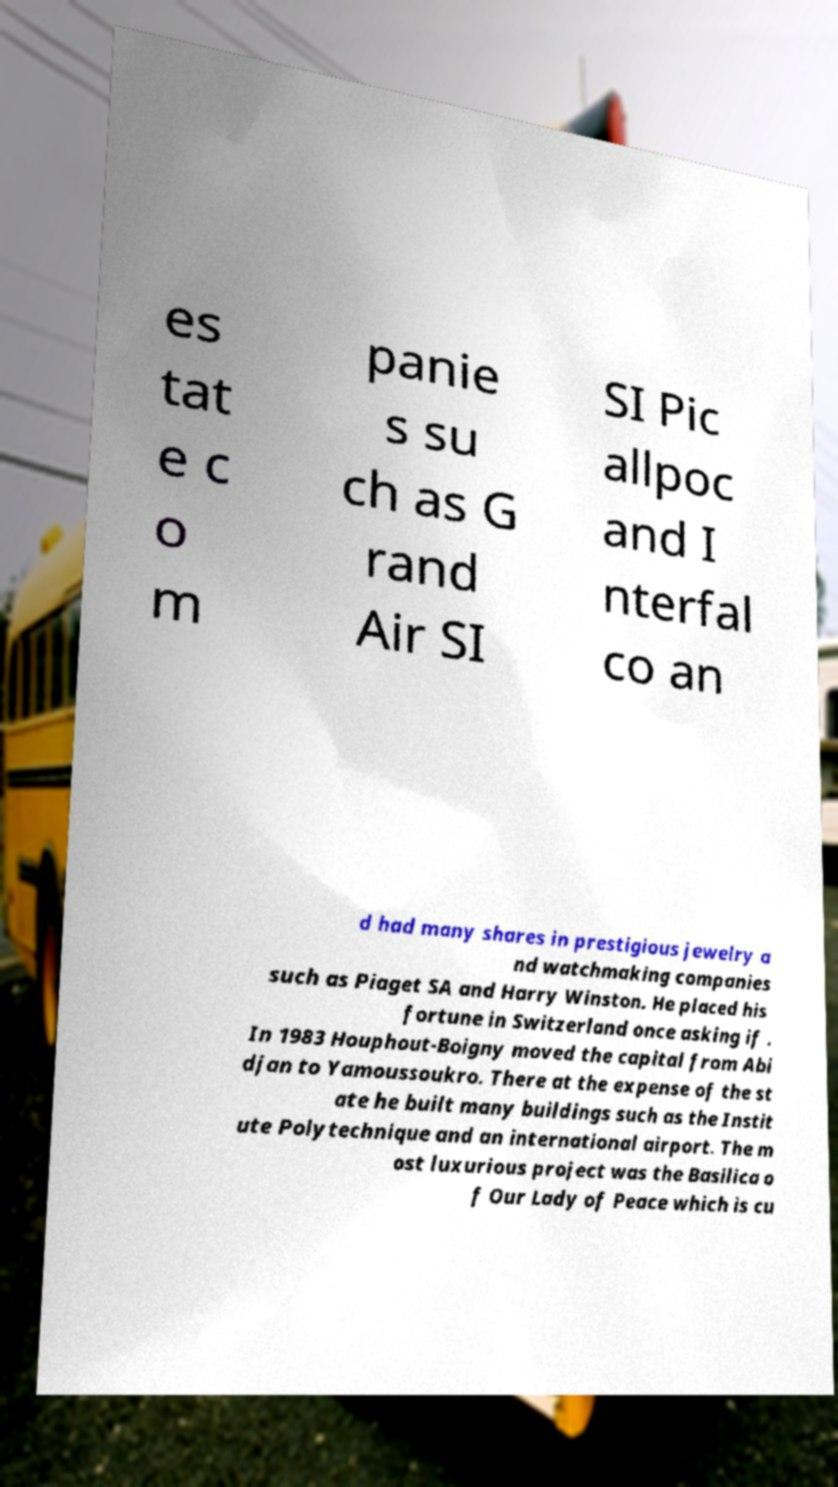Could you assist in decoding the text presented in this image and type it out clearly? es tat e c o m panie s su ch as G rand Air SI SI Pic allpoc and I nterfal co an d had many shares in prestigious jewelry a nd watchmaking companies such as Piaget SA and Harry Winston. He placed his fortune in Switzerland once asking if . In 1983 Houphout-Boigny moved the capital from Abi djan to Yamoussoukro. There at the expense of the st ate he built many buildings such as the Instit ute Polytechnique and an international airport. The m ost luxurious project was the Basilica o f Our Lady of Peace which is cu 